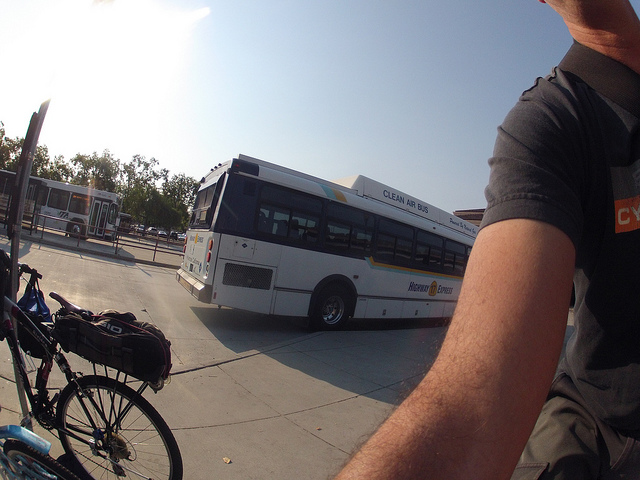<image>What shipping truck is in the background? There is no shipping truck in the background. However, if there is, it might be a FedEx truck. Who does the man work for? I don't know who the man works for. It could be 'rta', 'city', 'bus', 'cvs', 'bus company', or 'cy'. Was the photo taken on a park? I am not sure if the photo was taken on a park. It can be both yes and no. Does the man have on a tee shirt underneath his shirt? I am not sure if the man has a tee shirt underneath his shirt. What shipping truck is in the background? I don't know what shipping truck is in the background. It can be both fedex or bus. Who does the man work for? It is ambiguous who the man works for. It could be 'rta', 'city', 'bus', 'cvs', 'bus company', 'unknown', 'cy', or 'camera angle'. Was the photo taken on a park? I am not sure if the photo was taken in a park. It can be both yes or no. Does the man have on a tee shirt underneath his shirt? I am not sure if the man has on a tee shirt underneath his shirt. It can be both no or yes. 